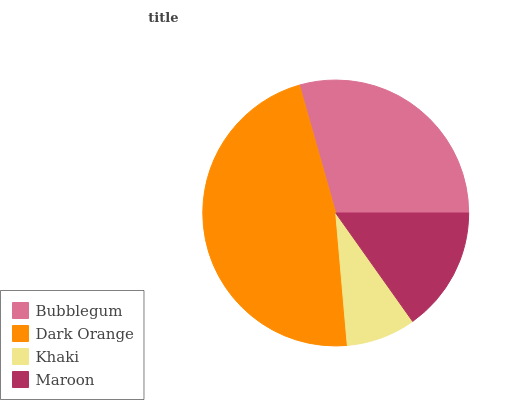Is Khaki the minimum?
Answer yes or no. Yes. Is Dark Orange the maximum?
Answer yes or no. Yes. Is Dark Orange the minimum?
Answer yes or no. No. Is Khaki the maximum?
Answer yes or no. No. Is Dark Orange greater than Khaki?
Answer yes or no. Yes. Is Khaki less than Dark Orange?
Answer yes or no. Yes. Is Khaki greater than Dark Orange?
Answer yes or no. No. Is Dark Orange less than Khaki?
Answer yes or no. No. Is Bubblegum the high median?
Answer yes or no. Yes. Is Maroon the low median?
Answer yes or no. Yes. Is Dark Orange the high median?
Answer yes or no. No. Is Bubblegum the low median?
Answer yes or no. No. 